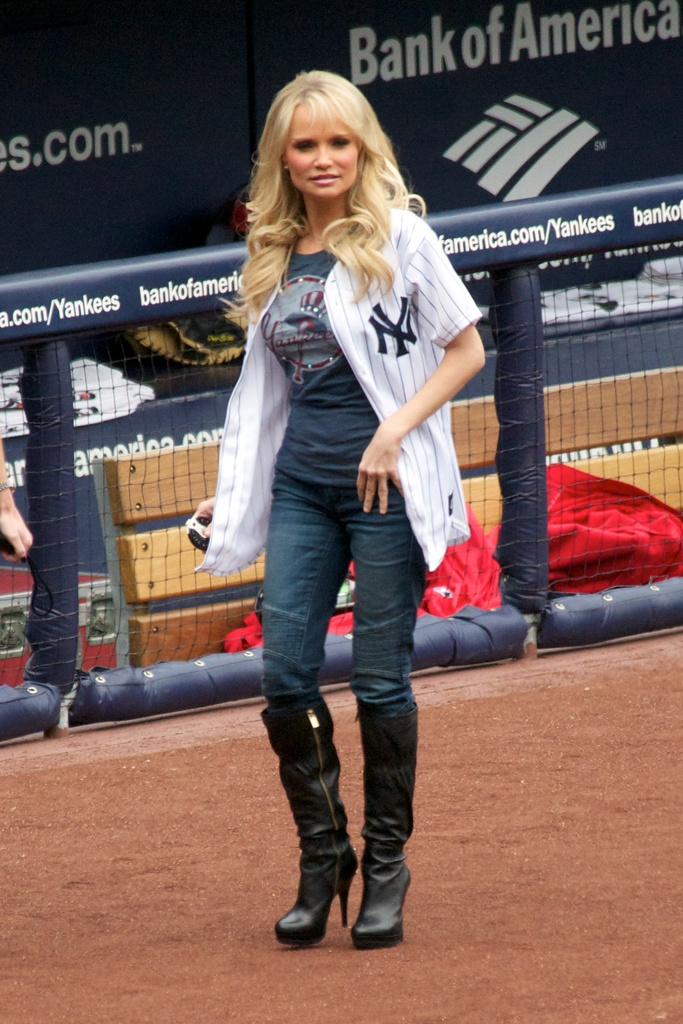Can you describe the attire of the woman in the provided image and what it suggests about her role at the event? The woman is wearing a Yankees jersey over a casual outfit paired with elegant high boots, suggesting she might be a special guest or celebrity involved in a promotional appearance or event at the game. 